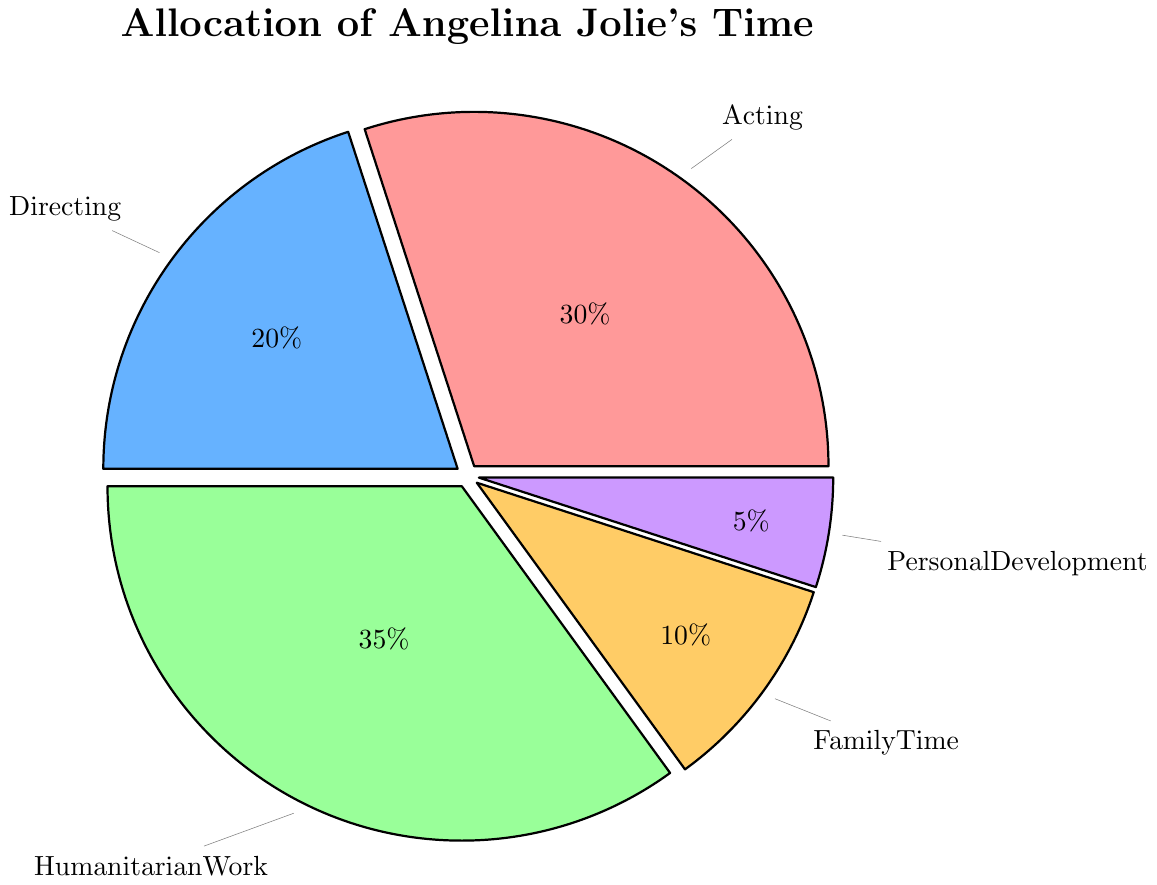What's the total percentage of time Angelina Jolie spends on Acting and Directing? To find the total percentage, add the percentages for Acting and Directing, which are 30% and 20%. 30 + 20 = 50
Answer: 50 Which activity does Angelina Jolie spend the most time on? By referring to the chart, we see that the section for Humanitarian Work is the largest at 35%. Thus, she spends the most time on Humanitarian Work.
Answer: Humanitarian Work Which activity does Angelina Jolie spend the least time on? The smallest slice of the pie chart represents Personal Development at 5%. Therefore, she spends the least time on Personal Development.
Answer: Personal Development Does Angelina Jolie spend more time on Family Time than on Personal Development? Compare the percentages for Family Time and Personal Development. Family Time is 10%, while Personal Development is 5%. 10% is greater than 5%.
Answer: Yes What's the difference between the time spent on Acting and Humanitarian Work? Subtract the percentage for Acting from the percentage for Humanitarian Work. 35 - 30 = 5
Answer: 5 Which two activities combined have the same percentage as Humanitarian Work? We need to find two activities adding up to 35%. Acting (30%) and Personal Development (5%) combine to equal 35%.
Answer: Acting and Personal Development What's the total percentage of time spent on Directing, Family Time, and Personal Development combined? Add up percentages for Directing (20%), Family Time (10%), and Personal Development (5%). 20 + 10 + 5 = 35
Answer: 35 Arrange the activities in ascending order of the time spent on them. Review the percentages for each activity and arrange them: Personal Development (5%), Family Time (10%), Directing (20%), Acting (30%), Humanitarian Work (35%).
Answer: Personal Development, Family Time, Directing, Acting, Humanitarian Work What percentage of Angelina Jolie's time is not spent on Acting or Humanitarian Work? Subtract the sum of percentages spent on Acting and Humanitarian Work from 100%. Acting is 30%, Humanitarian Work is 35%, so 100 - (30 + 35) = 35
Answer: 35 What color represents the Directing activity on the pie chart? By referring to the colors in the chart legend, the slice representing Directing is blue.
Answer: Blue 